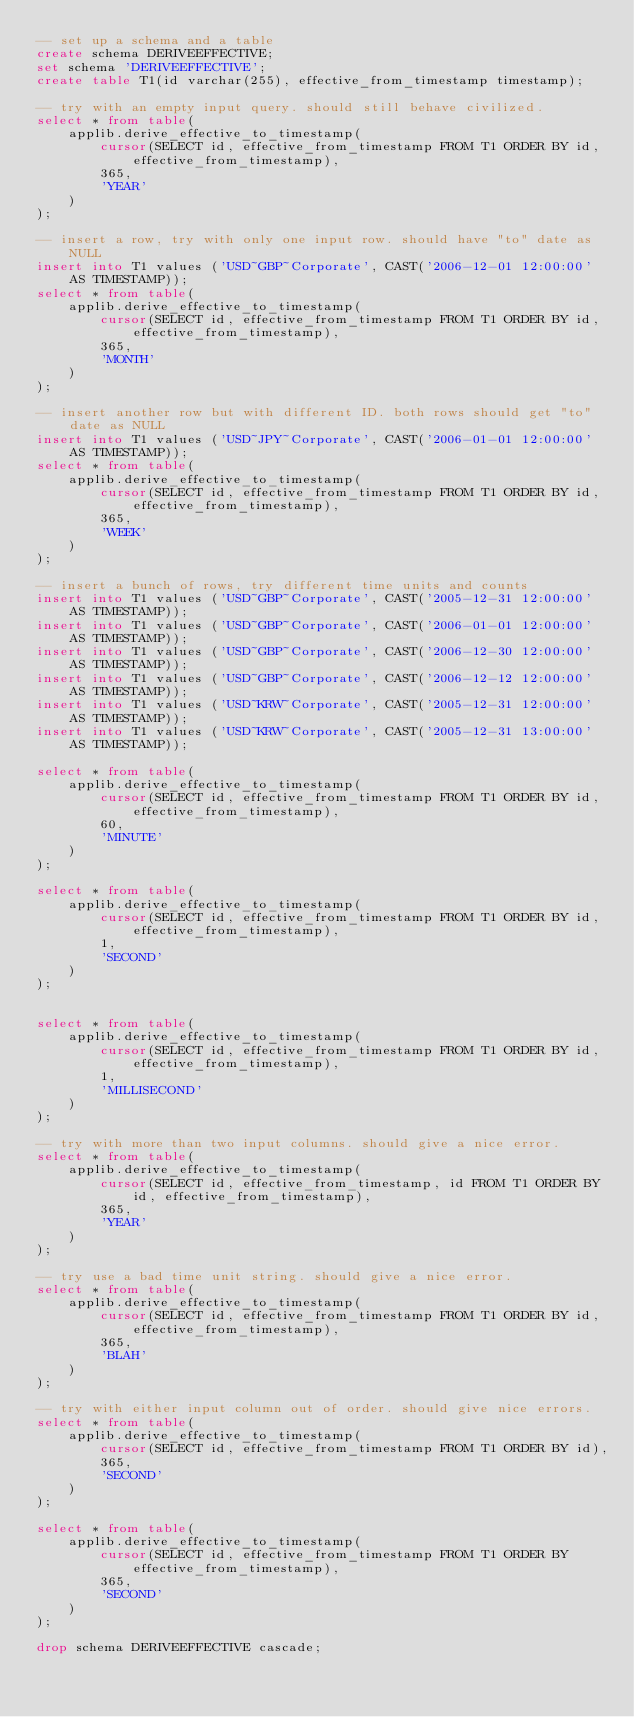<code> <loc_0><loc_0><loc_500><loc_500><_SQL_>-- set up a schema and a table
create schema DERIVEEFFECTIVE;
set schema 'DERIVEEFFECTIVE';
create table T1(id varchar(255), effective_from_timestamp timestamp);

-- try with an empty input query. should still behave civilized.
select * from table(
    applib.derive_effective_to_timestamp(
        cursor(SELECT id, effective_from_timestamp FROM T1 ORDER BY id, effective_from_timestamp),
        365,
        'YEAR'
    )
);

-- insert a row, try with only one input row. should have "to" date as NULL
insert into T1 values ('USD~GBP~Corporate', CAST('2006-12-01 12:00:00' AS TIMESTAMP));
select * from table(
    applib.derive_effective_to_timestamp(
        cursor(SELECT id, effective_from_timestamp FROM T1 ORDER BY id, effective_from_timestamp),
        365,
        'MONTH'
    )
);

-- insert another row but with different ID. both rows should get "to" date as NULL
insert into T1 values ('USD~JPY~Corporate', CAST('2006-01-01 12:00:00' AS TIMESTAMP));
select * from table(
    applib.derive_effective_to_timestamp(
        cursor(SELECT id, effective_from_timestamp FROM T1 ORDER BY id, effective_from_timestamp),
        365,
        'WEEK'
    )
);

-- insert a bunch of rows, try different time units and counts
insert into T1 values ('USD~GBP~Corporate', CAST('2005-12-31 12:00:00' AS TIMESTAMP));
insert into T1 values ('USD~GBP~Corporate', CAST('2006-01-01 12:00:00' AS TIMESTAMP));
insert into T1 values ('USD~GBP~Corporate', CAST('2006-12-30 12:00:00' AS TIMESTAMP));
insert into T1 values ('USD~GBP~Corporate', CAST('2006-12-12 12:00:00' AS TIMESTAMP));
insert into T1 values ('USD~KRW~Corporate', CAST('2005-12-31 12:00:00' AS TIMESTAMP));
insert into T1 values ('USD~KRW~Corporate', CAST('2005-12-31 13:00:00' AS TIMESTAMP));

select * from table(
    applib.derive_effective_to_timestamp(
        cursor(SELECT id, effective_from_timestamp FROM T1 ORDER BY id, effective_from_timestamp),
        60,
        'MINUTE'
    )
);

select * from table(
    applib.derive_effective_to_timestamp(
        cursor(SELECT id, effective_from_timestamp FROM T1 ORDER BY id, effective_from_timestamp),
        1,
        'SECOND'
    )
);


select * from table(
    applib.derive_effective_to_timestamp(
        cursor(SELECT id, effective_from_timestamp FROM T1 ORDER BY id, effective_from_timestamp),
        1,
        'MILLISECOND'
    )
);

-- try with more than two input columns. should give a nice error.
select * from table(
    applib.derive_effective_to_timestamp(
        cursor(SELECT id, effective_from_timestamp, id FROM T1 ORDER BY id, effective_from_timestamp),
        365,
        'YEAR'
    )
);

-- try use a bad time unit string. should give a nice error.
select * from table(
    applib.derive_effective_to_timestamp(
        cursor(SELECT id, effective_from_timestamp FROM T1 ORDER BY id, effective_from_timestamp),
        365,
        'BLAH'
    )
);

-- try with either input column out of order. should give nice errors.
select * from table(
    applib.derive_effective_to_timestamp(
        cursor(SELECT id, effective_from_timestamp FROM T1 ORDER BY id),
        365,
        'SECOND'
    )
);

select * from table(
    applib.derive_effective_to_timestamp(
        cursor(SELECT id, effective_from_timestamp FROM T1 ORDER BY effective_from_timestamp),
        365,
        'SECOND'
    )
);

drop schema DERIVEEFFECTIVE cascade;
</code> 